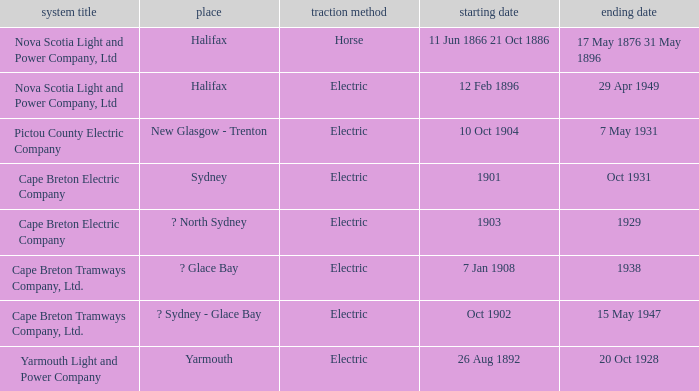What is the date (to) associated wiht a traction type of electric and the Yarmouth Light and Power Company system? 20 Oct 1928. 